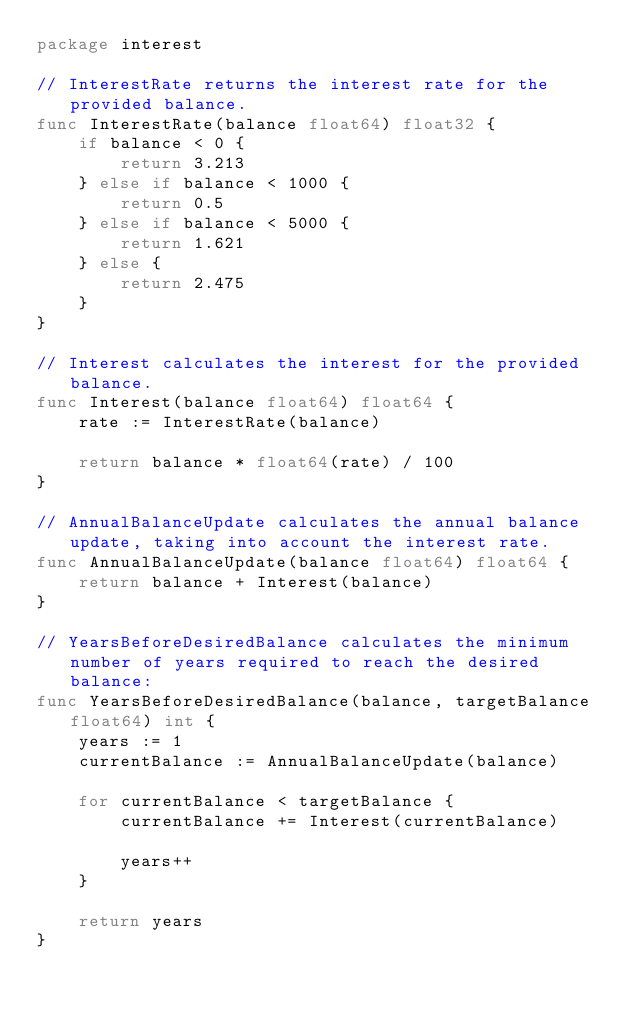Convert code to text. <code><loc_0><loc_0><loc_500><loc_500><_Go_>package interest

// InterestRate returns the interest rate for the provided balance.
func InterestRate(balance float64) float32 {
	if balance < 0 {
		return 3.213
	} else if balance < 1000 {
		return 0.5
	} else if balance < 5000 {
		return 1.621
	} else {
		return 2.475
	}
}

// Interest calculates the interest for the provided balance.
func Interest(balance float64) float64 {
	rate := InterestRate(balance)

	return balance * float64(rate) / 100
}

// AnnualBalanceUpdate calculates the annual balance update, taking into account the interest rate.
func AnnualBalanceUpdate(balance float64) float64 {
	return balance + Interest(balance)
}

// YearsBeforeDesiredBalance calculates the minimum number of years required to reach the desired balance:
func YearsBeforeDesiredBalance(balance, targetBalance float64) int {
	years := 1
	currentBalance := AnnualBalanceUpdate(balance)

	for currentBalance < targetBalance {
		currentBalance += Interest(currentBalance)

		years++
	}

	return years
}
</code> 